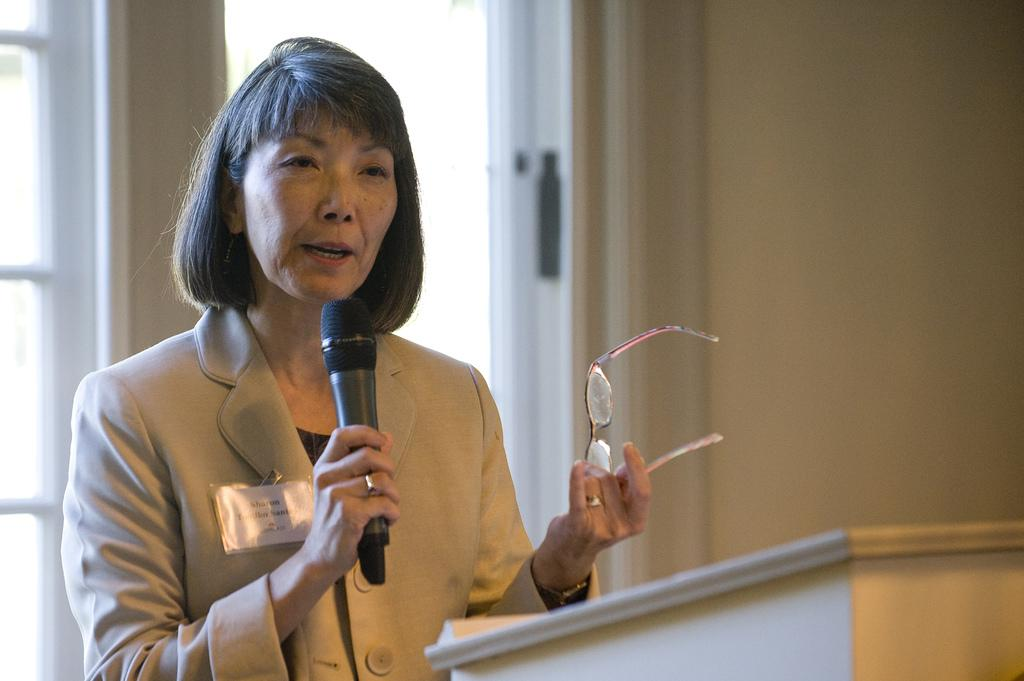Who is the main subject in the image? There is a woman in the image. What is the woman doing in the image? The woman is standing in front of a podium and holding a mic. What else is the woman holding in the image? The woman is holding spectacles. What can be seen in the background of the image? There is a wall in the background of the image. How does the boy use the hook in the image? There is no boy or hook present in the image. 